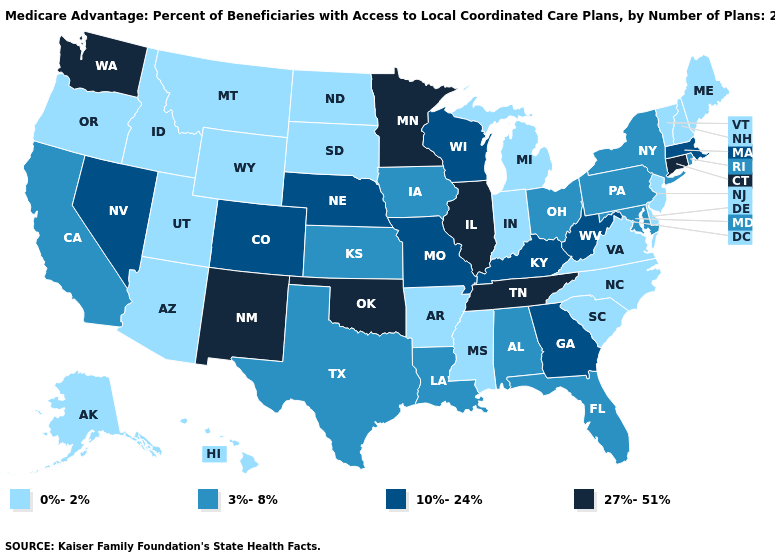Name the states that have a value in the range 10%-24%?
Short answer required. Colorado, Georgia, Kentucky, Massachusetts, Missouri, Nebraska, Nevada, Wisconsin, West Virginia. Does the map have missing data?
Quick response, please. No. Among the states that border Oregon , which have the highest value?
Short answer required. Washington. Is the legend a continuous bar?
Concise answer only. No. Name the states that have a value in the range 3%-8%?
Write a very short answer. Alabama, California, Florida, Iowa, Kansas, Louisiana, Maryland, New York, Ohio, Pennsylvania, Rhode Island, Texas. Among the states that border Michigan , which have the lowest value?
Concise answer only. Indiana. What is the value of South Dakota?
Short answer required. 0%-2%. Among the states that border New Hampshire , does Massachusetts have the lowest value?
Concise answer only. No. Name the states that have a value in the range 10%-24%?
Keep it brief. Colorado, Georgia, Kentucky, Massachusetts, Missouri, Nebraska, Nevada, Wisconsin, West Virginia. Does Connecticut have the highest value in the USA?
Write a very short answer. Yes. Does Ohio have a lower value than Delaware?
Keep it brief. No. Does Ohio have a lower value than Washington?
Concise answer only. Yes. Which states have the highest value in the USA?
Answer briefly. Connecticut, Illinois, Minnesota, New Mexico, Oklahoma, Tennessee, Washington. What is the value of Massachusetts?
Keep it brief. 10%-24%. Among the states that border Nebraska , does Wyoming have the lowest value?
Quick response, please. Yes. 